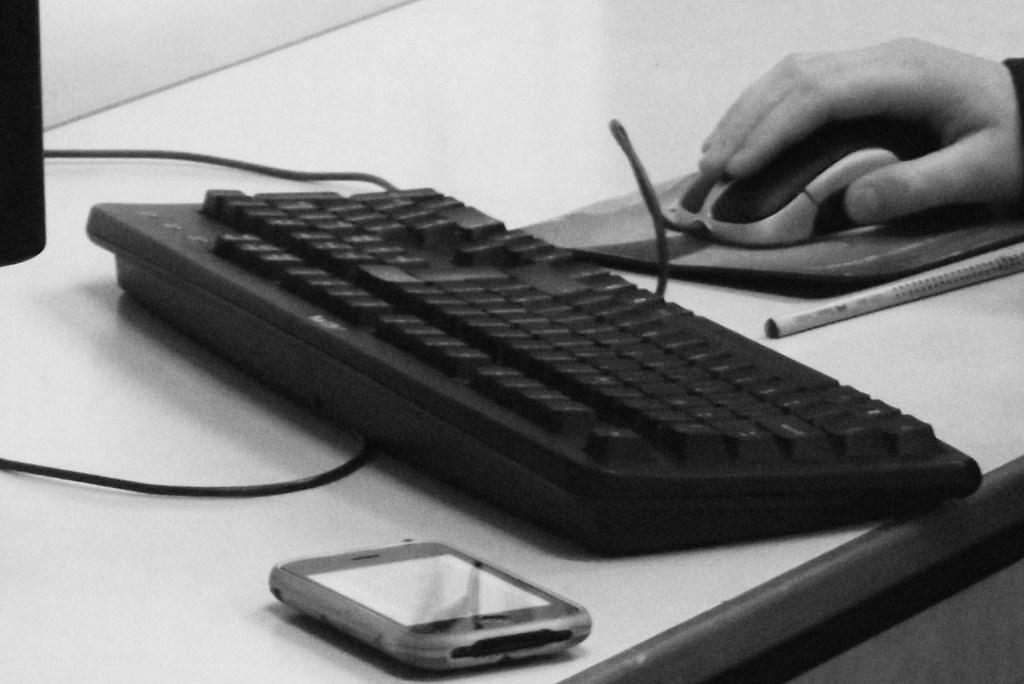Describe this image in one or two sentences. In this image we can see a keyboard ,a mobile and a mouse which is held by person's hand are placed on the table along with a pen. 